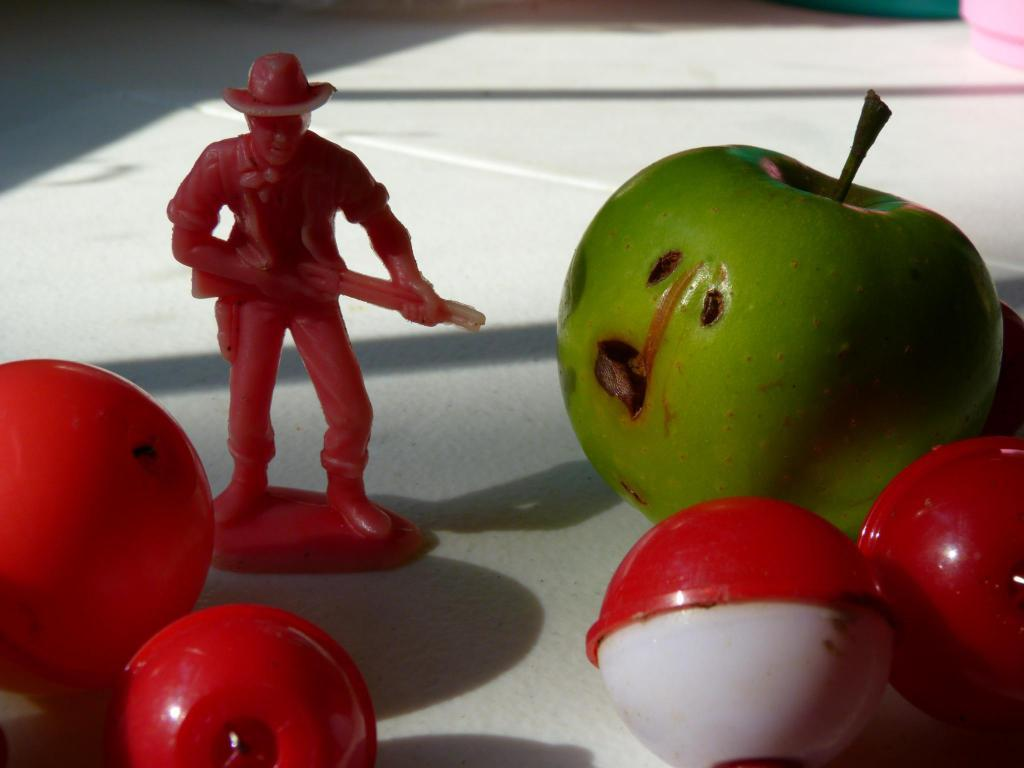What is the main subject of the image? There is a depiction of a person in the image. What other objects can be seen in the image? There are balls and a fruit on a table in the image. What is the opinion of the bead about the distance between the person and the fruit in the image? There is no bead present in the image, and therefore it cannot have an opinion about the distance between the person and the fruit. 